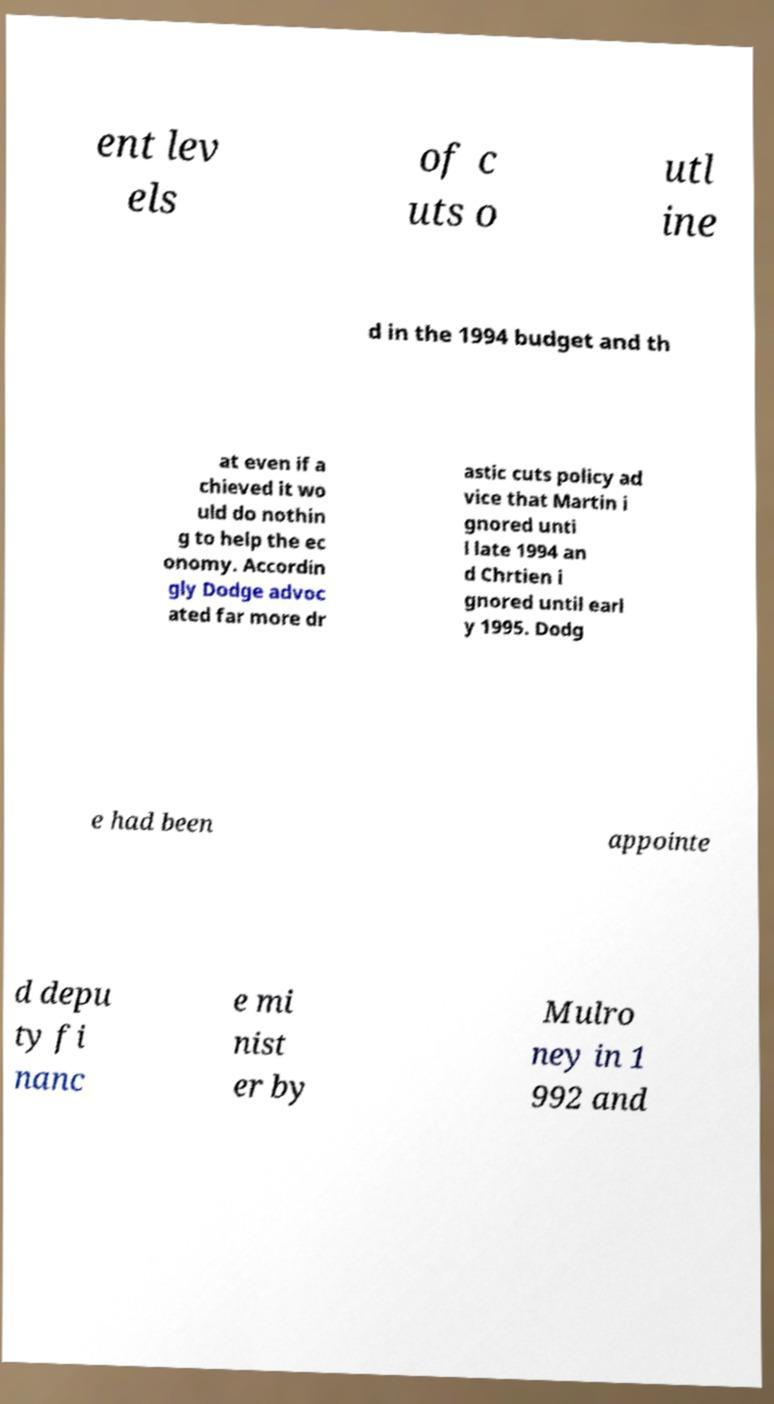Can you accurately transcribe the text from the provided image for me? ent lev els of c uts o utl ine d in the 1994 budget and th at even if a chieved it wo uld do nothin g to help the ec onomy. Accordin gly Dodge advoc ated far more dr astic cuts policy ad vice that Martin i gnored unti l late 1994 an d Chrtien i gnored until earl y 1995. Dodg e had been appointe d depu ty fi nanc e mi nist er by Mulro ney in 1 992 and 